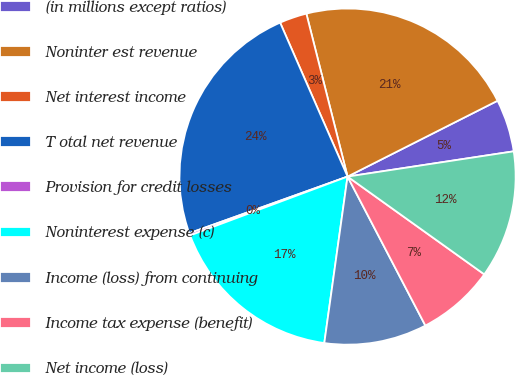<chart> <loc_0><loc_0><loc_500><loc_500><pie_chart><fcel>(in millions except ratios)<fcel>Noninter est revenue<fcel>Net interest income<fcel>T otal net revenue<fcel>Provision for credit losses<fcel>Noninterest expense (c)<fcel>Income (loss) from continuing<fcel>Income tax expense (benefit)<fcel>Net income (loss)<nl><fcel>5.05%<fcel>21.49%<fcel>2.63%<fcel>23.9%<fcel>0.22%<fcel>17.1%<fcel>9.87%<fcel>7.46%<fcel>12.28%<nl></chart> 